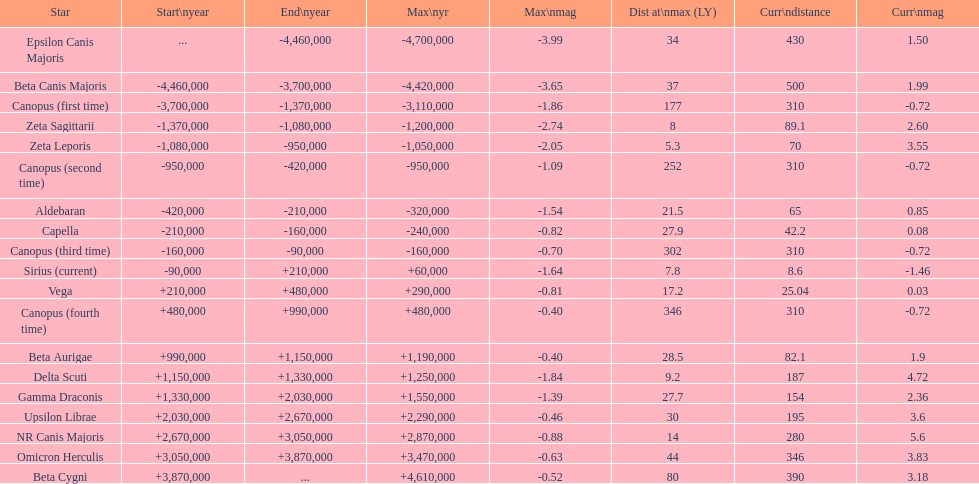Is capella's current magnitude more than vega's current magnitude? Yes. 